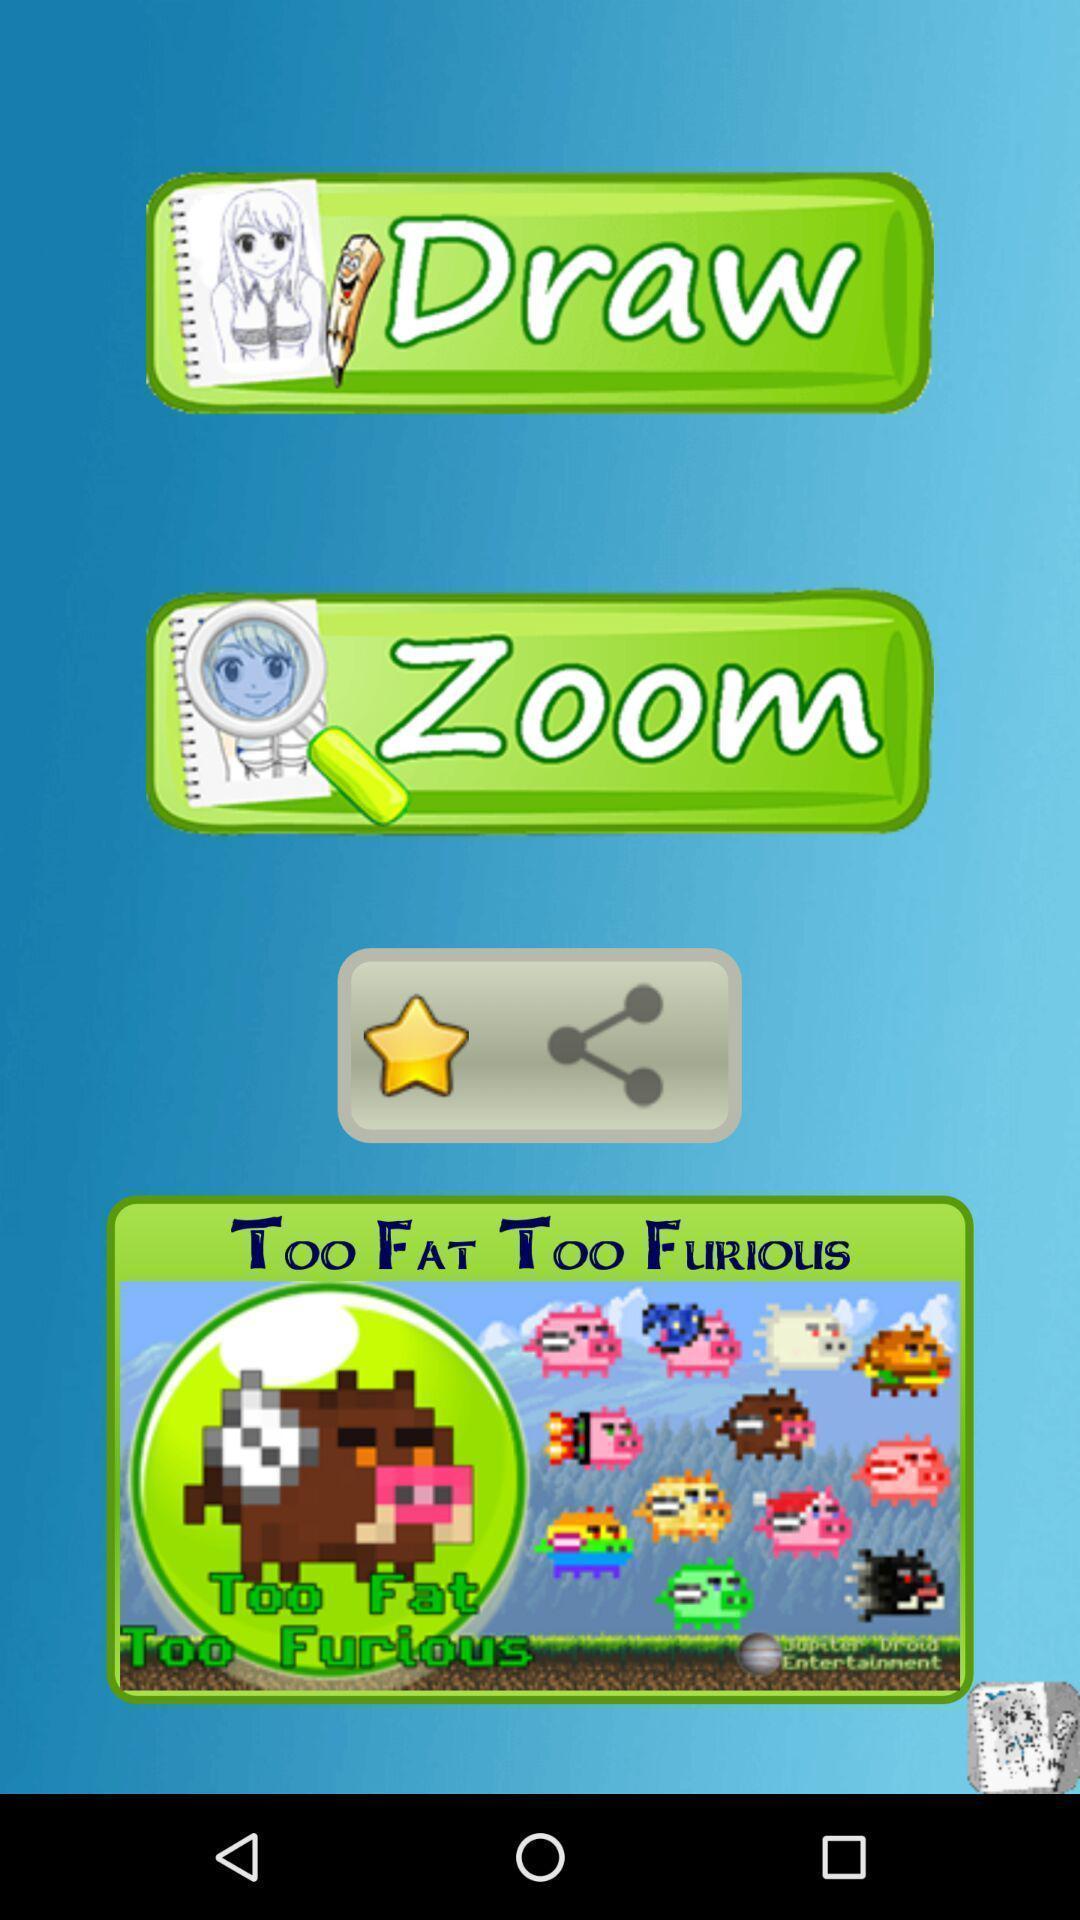Describe the content in this image. Page showing different games available. 